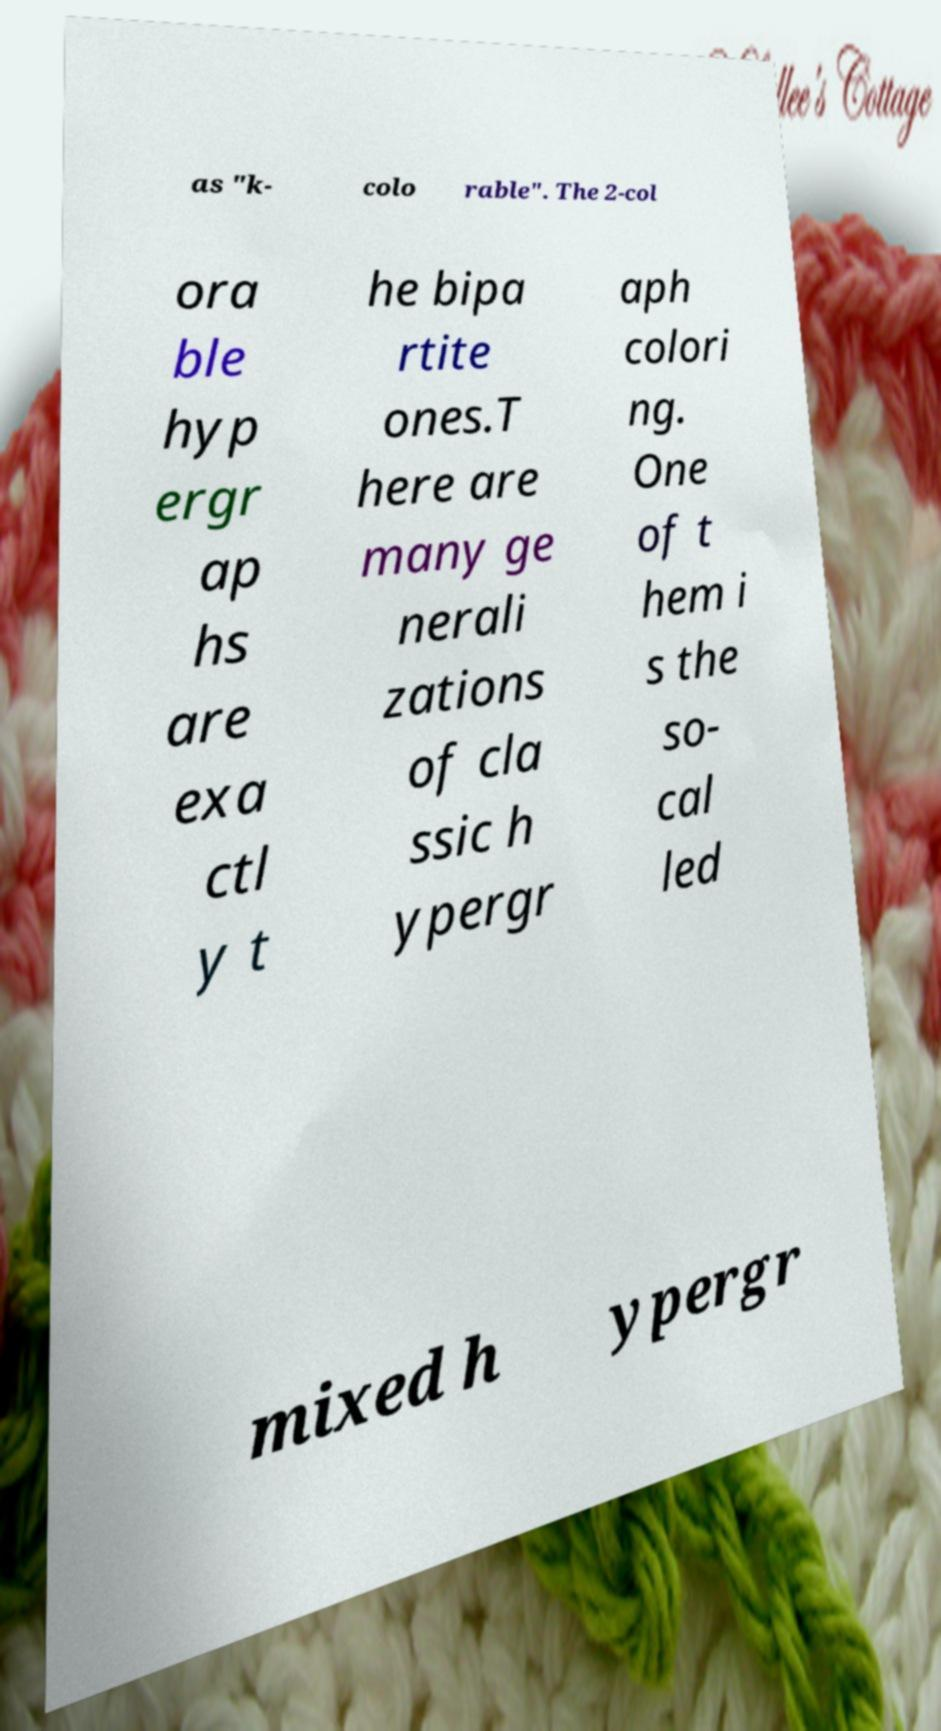Please read and relay the text visible in this image. What does it say? as "k- colo rable". The 2-col ora ble hyp ergr ap hs are exa ctl y t he bipa rtite ones.T here are many ge nerali zations of cla ssic h ypergr aph colori ng. One of t hem i s the so- cal led mixed h ypergr 